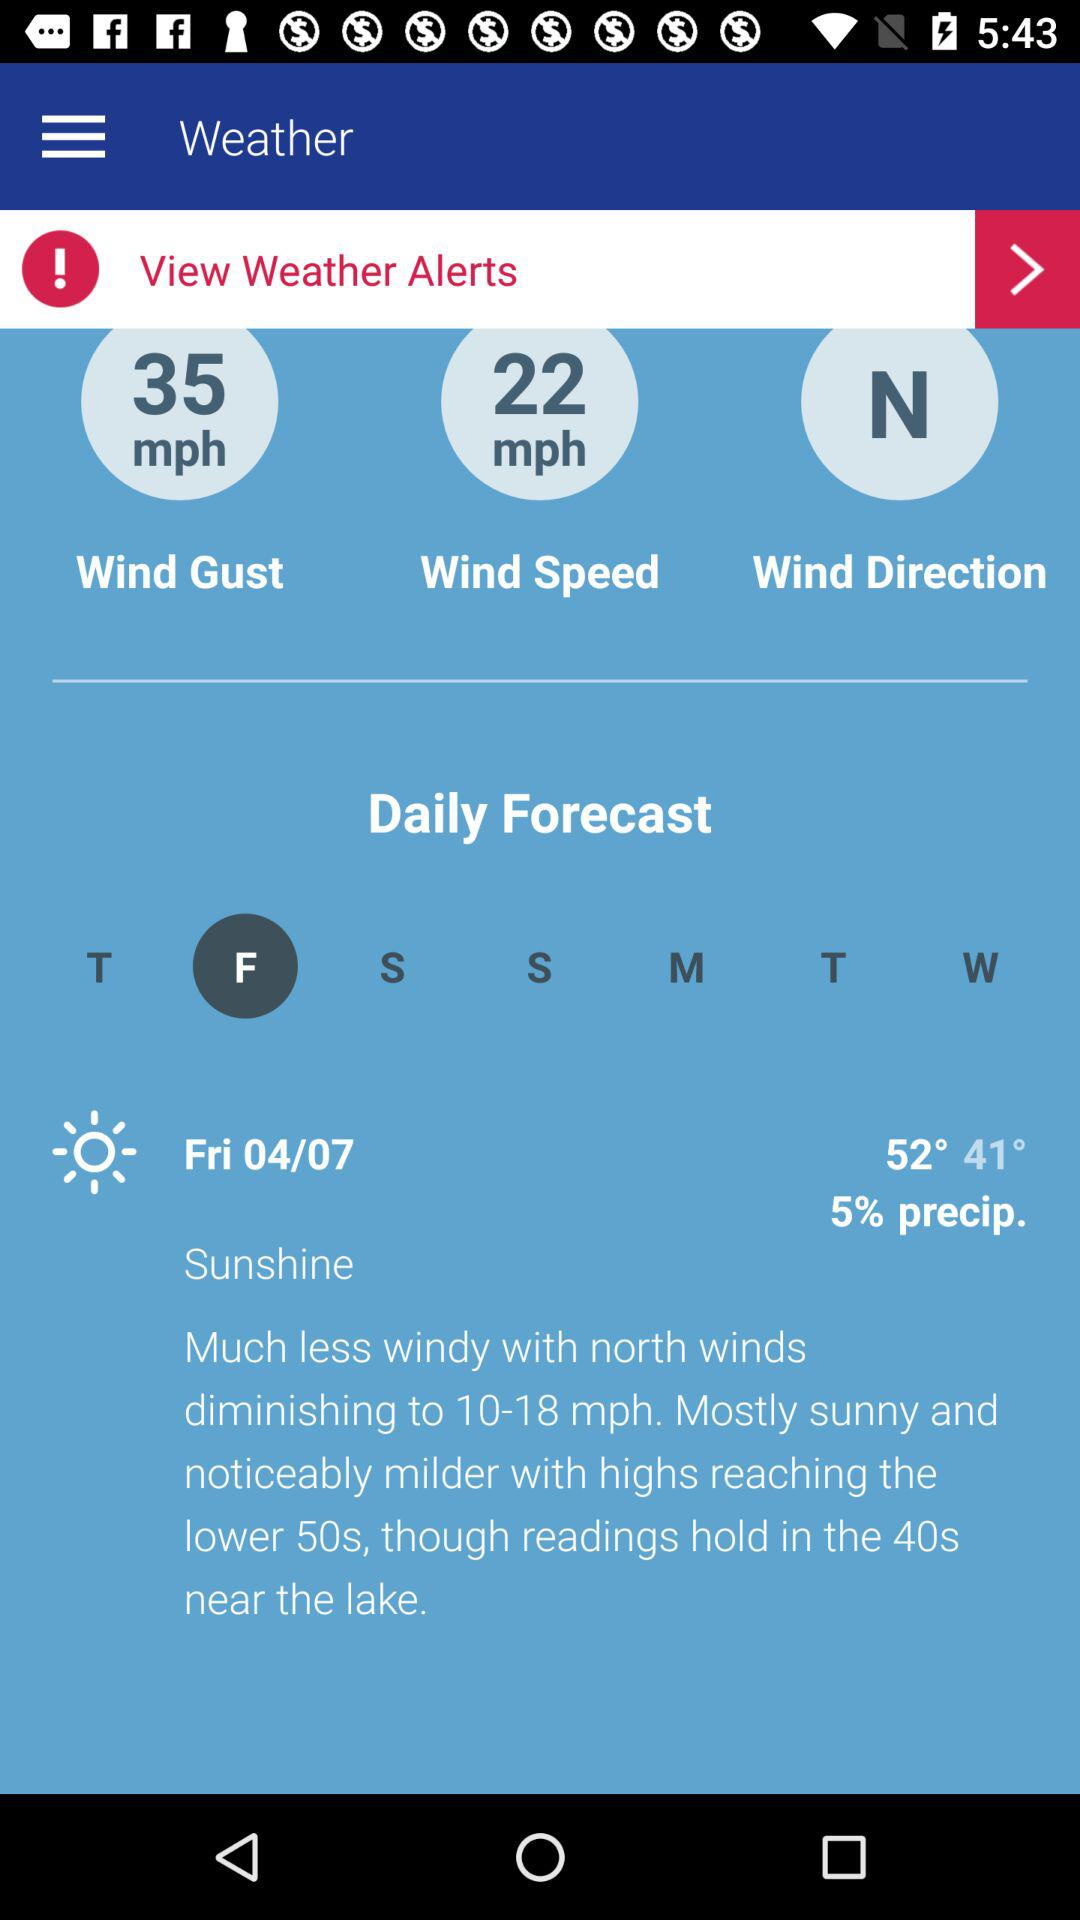What is the precipitation percentage? The precipitation is 5%. 